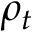Convert formula to latex. <formula><loc_0><loc_0><loc_500><loc_500>\rho _ { t }</formula> 